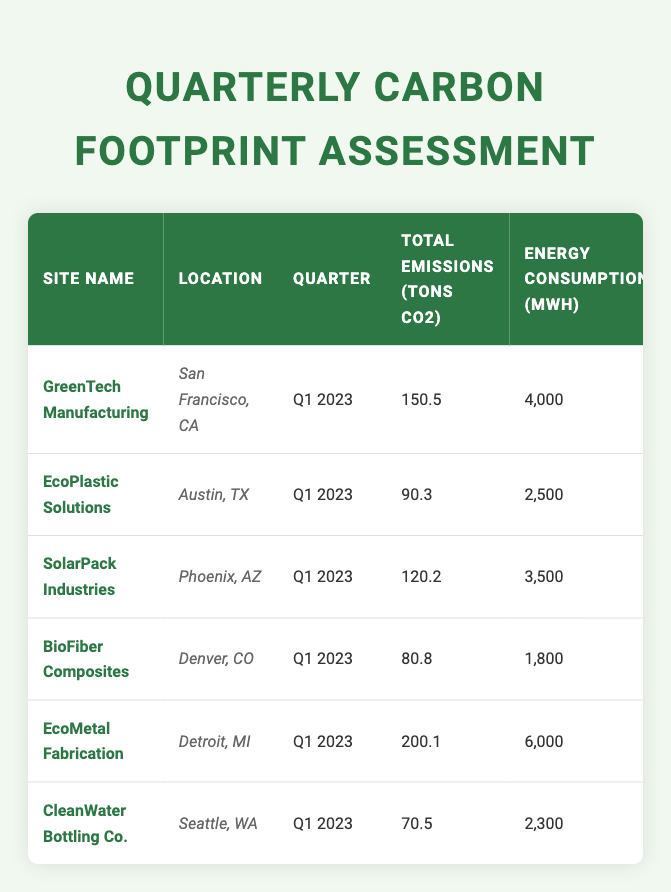What site has the highest total emissions in Q1 2023? By comparing the "Total Emissions (tons CO2)" column, EcoMetal Fabrication has the highest value at 200.1 tons.
Answer: EcoMetal Fabrication What is the renewable energy percentage for CleanWater Bottling Co.? From the table, CleanWater Bottling Co. has a renewable energy percentage of 85%.
Answer: 85% What is the total waste generated by all sites in Q1 2023? Summing the waste generated by each site: (25 + 15 + 20 + 10 + 30 + 5) = 105 tons.
Answer: 105 tons Which site has the lowest energy consumption? By examining the "Energy Consumption (MWh)" column, BioFiber Composites shows the lowest energy consumption at 1,800 MWh.
Answer: BioFiber Composites What are the average total emissions for the listed sites? To find the average total emissions, sum all emissions: (150.5 + 90.3 + 120.2 + 80.8 + 200.1 + 70.5) = 712.4 tons, then divide by 6 sites: 712.4 / 6 = approximately 118.73 tons.
Answer: Approximately 118.73 tons Is the renewable energy percentage for EcoPlastic Solutions greater than 70%? EcoPlastic Solutions has a renewable energy percentage of 65%, which is not greater than 70%, so the answer is false.
Answer: False Which site has the lowest water usage among the sites? The "Water Usage (gallons)" shows CleanWater Bottling Co. has the lowest at 35,000 gallons used.
Answer: CleanWater Bottling Co What is the difference in carbon offset investment between EcoMetal Fabrication and BioFiber Composites? EcoMetal Fabrication invested $30,000 and BioFiber Composites invested $10,000; the difference is $30,000 - $10,000 = $20,000.
Answer: $20,000 Calculate the total carbon offset investment across all sites. Adding all investments: (20000 + 15000 + 25000 + 10000 + 30000 + 8000) = $108,000.
Answer: $108,000 Does SolarPack Industries have a higher total emissions compared to EcoPlastic Solutions? SolarPack Industries emitted 120.2 tons, while EcoPlastic Solutions emitted 90.3 tons, showing that SolarPack does have higher emissions.
Answer: Yes 